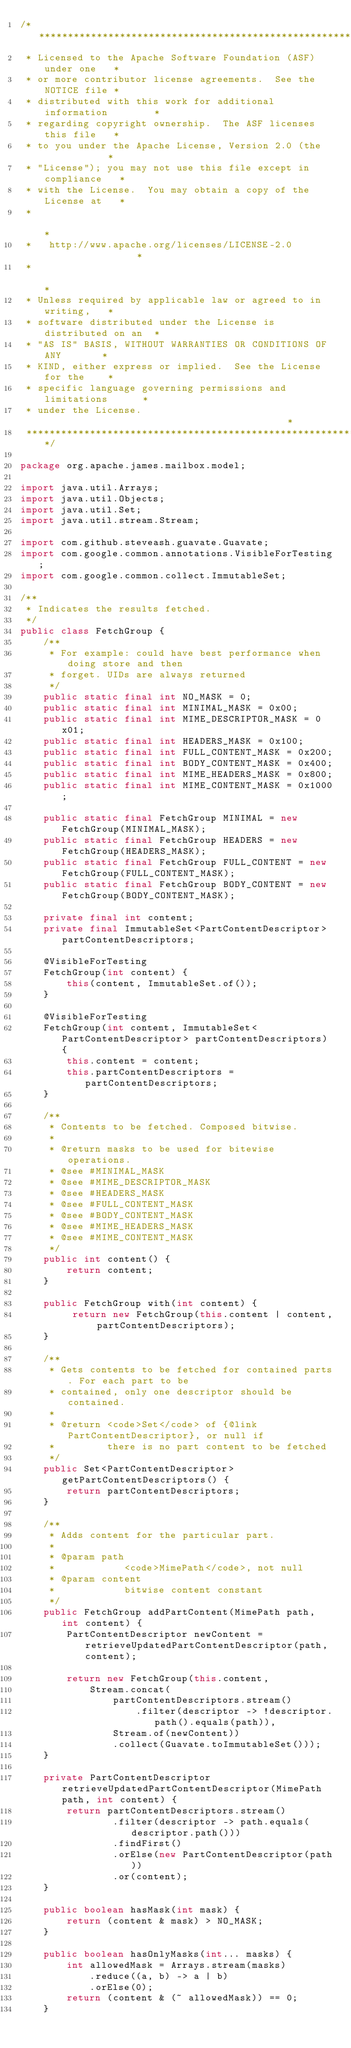<code> <loc_0><loc_0><loc_500><loc_500><_Java_>/****************************************************************
 * Licensed to the Apache Software Foundation (ASF) under one   *
 * or more contributor license agreements.  See the NOTICE file *
 * distributed with this work for additional information        *
 * regarding copyright ownership.  The ASF licenses this file   *
 * to you under the Apache License, Version 2.0 (the            *
 * "License"); you may not use this file except in compliance   *
 * with the License.  You may obtain a copy of the License at   *
 *                                                              *
 *   http://www.apache.org/licenses/LICENSE-2.0                 *
 *                                                              *
 * Unless required by applicable law or agreed to in writing,   *
 * software distributed under the License is distributed on an  *
 * "AS IS" BASIS, WITHOUT WARRANTIES OR CONDITIONS OF ANY       *
 * KIND, either express or implied.  See the License for the    *
 * specific language governing permissions and limitations      *
 * under the License.                                           *
 ****************************************************************/

package org.apache.james.mailbox.model;

import java.util.Arrays;
import java.util.Objects;
import java.util.Set;
import java.util.stream.Stream;

import com.github.steveash.guavate.Guavate;
import com.google.common.annotations.VisibleForTesting;
import com.google.common.collect.ImmutableSet;

/**
 * Indicates the results fetched.
 */
public class FetchGroup {
    /**
     * For example: could have best performance when doing store and then
     * forget. UIDs are always returned
     */
    public static final int NO_MASK = 0;
    public static final int MINIMAL_MASK = 0x00;
    public static final int MIME_DESCRIPTOR_MASK = 0x01;
    public static final int HEADERS_MASK = 0x100;
    public static final int FULL_CONTENT_MASK = 0x200;
    public static final int BODY_CONTENT_MASK = 0x400;
    public static final int MIME_HEADERS_MASK = 0x800;
    public static final int MIME_CONTENT_MASK = 0x1000;

    public static final FetchGroup MINIMAL = new FetchGroup(MINIMAL_MASK);
    public static final FetchGroup HEADERS = new FetchGroup(HEADERS_MASK);
    public static final FetchGroup FULL_CONTENT = new FetchGroup(FULL_CONTENT_MASK);
    public static final FetchGroup BODY_CONTENT = new FetchGroup(BODY_CONTENT_MASK);

    private final int content;
    private final ImmutableSet<PartContentDescriptor> partContentDescriptors;

    @VisibleForTesting
    FetchGroup(int content) {
        this(content, ImmutableSet.of());
    }

    @VisibleForTesting
    FetchGroup(int content, ImmutableSet<PartContentDescriptor> partContentDescriptors) {
        this.content = content;
        this.partContentDescriptors = partContentDescriptors;
    }

    /**
     * Contents to be fetched. Composed bitwise.
     *
     * @return masks to be used for bitewise operations.
     * @see #MINIMAL_MASK
     * @see #MIME_DESCRIPTOR_MASK
     * @see #HEADERS_MASK
     * @see #FULL_CONTENT_MASK
     * @see #BODY_CONTENT_MASK
     * @see #MIME_HEADERS_MASK
     * @see #MIME_CONTENT_MASK
     */
    public int content() {
        return content;
    }

    public FetchGroup with(int content) {
         return new FetchGroup(this.content | content, partContentDescriptors);
    }

    /**
     * Gets contents to be fetched for contained parts. For each part to be
     * contained, only one descriptor should be contained.
     *
     * @return <code>Set</code> of {@link PartContentDescriptor}, or null if
     *         there is no part content to be fetched
     */
    public Set<PartContentDescriptor> getPartContentDescriptors() {
        return partContentDescriptors;
    }

    /**
     * Adds content for the particular part.
     * 
     * @param path
     *            <code>MimePath</code>, not null
     * @param content
     *            bitwise content constant
     */
    public FetchGroup addPartContent(MimePath path, int content) {
        PartContentDescriptor newContent = retrieveUpdatedPartContentDescriptor(path, content);

        return new FetchGroup(this.content,
            Stream.concat(
                partContentDescriptors.stream()
                    .filter(descriptor -> !descriptor.path().equals(path)),
                Stream.of(newContent))
                .collect(Guavate.toImmutableSet()));
    }

    private PartContentDescriptor retrieveUpdatedPartContentDescriptor(MimePath path, int content) {
        return partContentDescriptors.stream()
                .filter(descriptor -> path.equals(descriptor.path()))
                .findFirst()
                .orElse(new PartContentDescriptor(path))
                .or(content);
    }

    public boolean hasMask(int mask) {
        return (content & mask) > NO_MASK;
    }

    public boolean hasOnlyMasks(int... masks) {
        int allowedMask = Arrays.stream(masks)
            .reduce((a, b) -> a | b)
            .orElse(0);
        return (content & (~ allowedMask)) == 0;
    }
</code> 